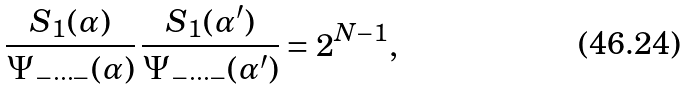Convert formula to latex. <formula><loc_0><loc_0><loc_500><loc_500>\frac { S _ { 1 } ( \alpha ) } { \Psi _ { - \cdots - } ( \alpha ) } \, \frac { S _ { 1 } ( \alpha ^ { \prime } ) } { \Psi _ { - \cdots - } ( \alpha ^ { \prime } ) } = 2 ^ { N - 1 } ,</formula> 